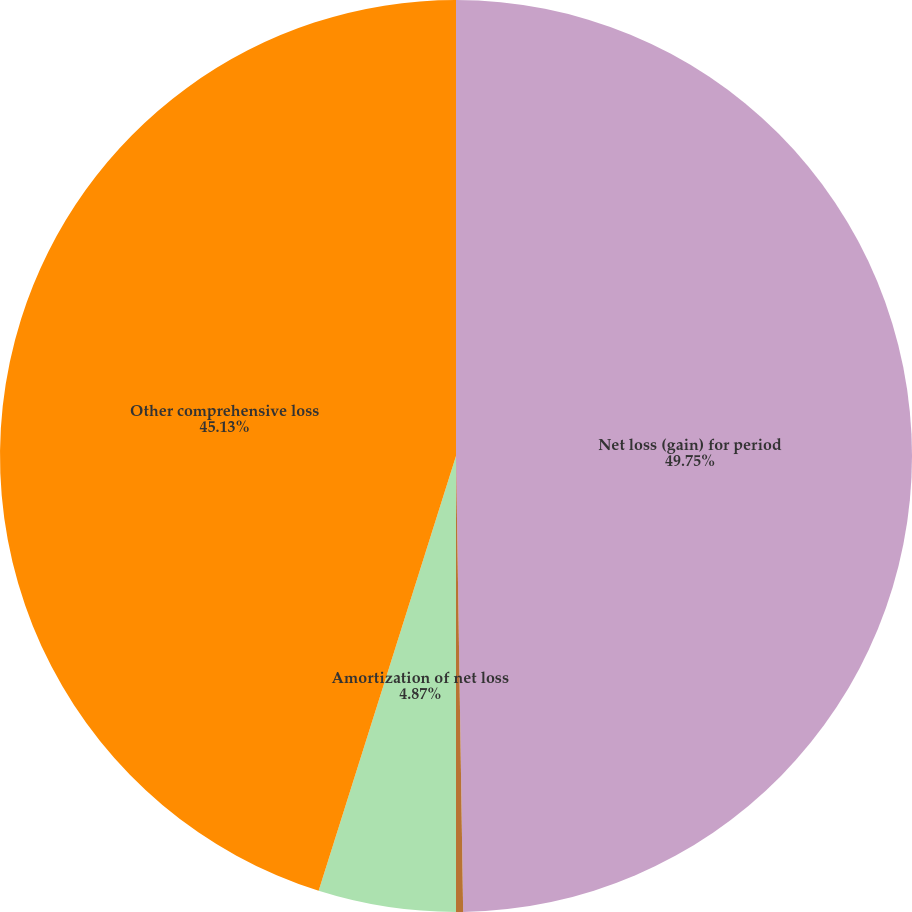Convert chart. <chart><loc_0><loc_0><loc_500><loc_500><pie_chart><fcel>Net loss (gain) for period<fcel>Amortization of prior service<fcel>Amortization of net loss<fcel>Other comprehensive loss<nl><fcel>49.75%<fcel>0.25%<fcel>4.87%<fcel>45.13%<nl></chart> 